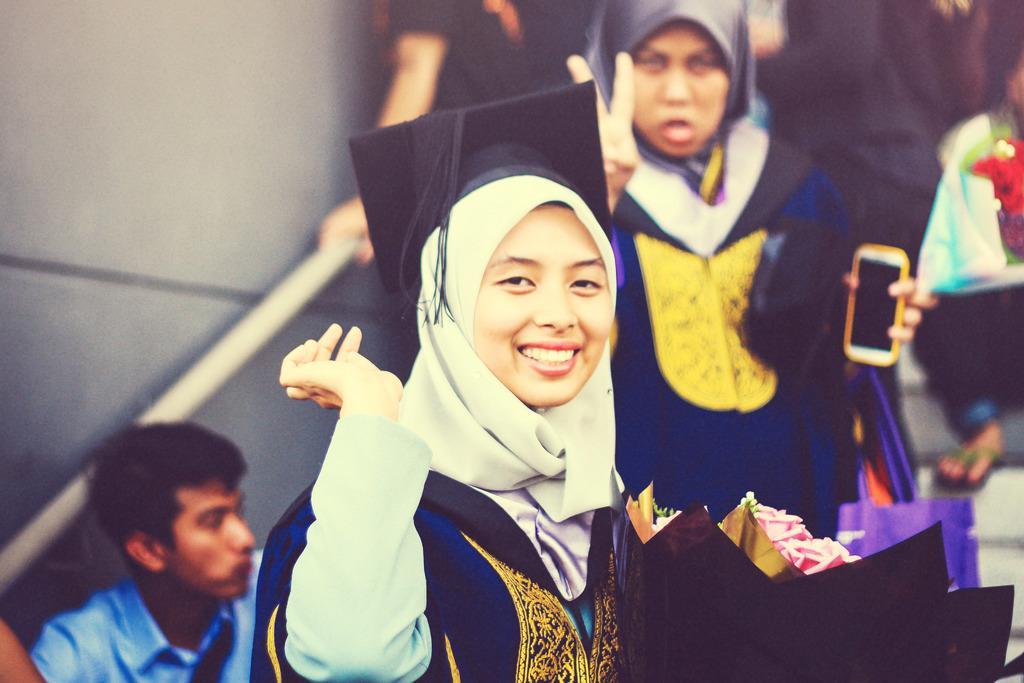Can you describe this image briefly? In this image, we can see persons wearing clothes. There is a wall mounted railing handle on the left side of the image. There is a person in the middle of the image holding a phone with her hand. 